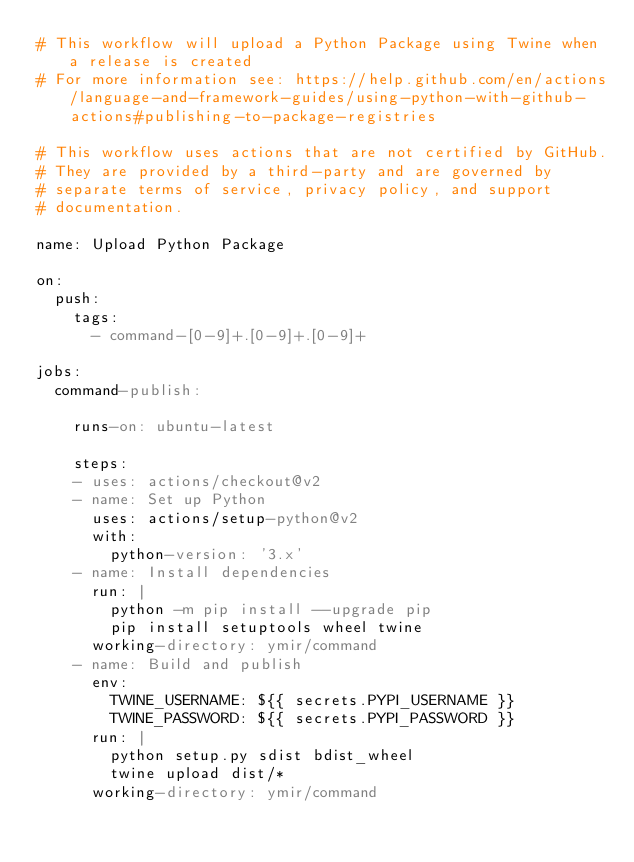<code> <loc_0><loc_0><loc_500><loc_500><_YAML_># This workflow will upload a Python Package using Twine when a release is created
# For more information see: https://help.github.com/en/actions/language-and-framework-guides/using-python-with-github-actions#publishing-to-package-registries

# This workflow uses actions that are not certified by GitHub.
# They are provided by a third-party and are governed by
# separate terms of service, privacy policy, and support
# documentation.

name: Upload Python Package

on:
  push:
    tags:
      - command-[0-9]+.[0-9]+.[0-9]+

jobs:
  command-publish:

    runs-on: ubuntu-latest

    steps:
    - uses: actions/checkout@v2
    - name: Set up Python
      uses: actions/setup-python@v2
      with:
        python-version: '3.x'
    - name: Install dependencies
      run: |
        python -m pip install --upgrade pip
        pip install setuptools wheel twine
      working-directory: ymir/command
    - name: Build and publish
      env:
        TWINE_USERNAME: ${{ secrets.PYPI_USERNAME }}
        TWINE_PASSWORD: ${{ secrets.PYPI_PASSWORD }}
      run: |
        python setup.py sdist bdist_wheel
        twine upload dist/*
      working-directory: ymir/command
</code> 